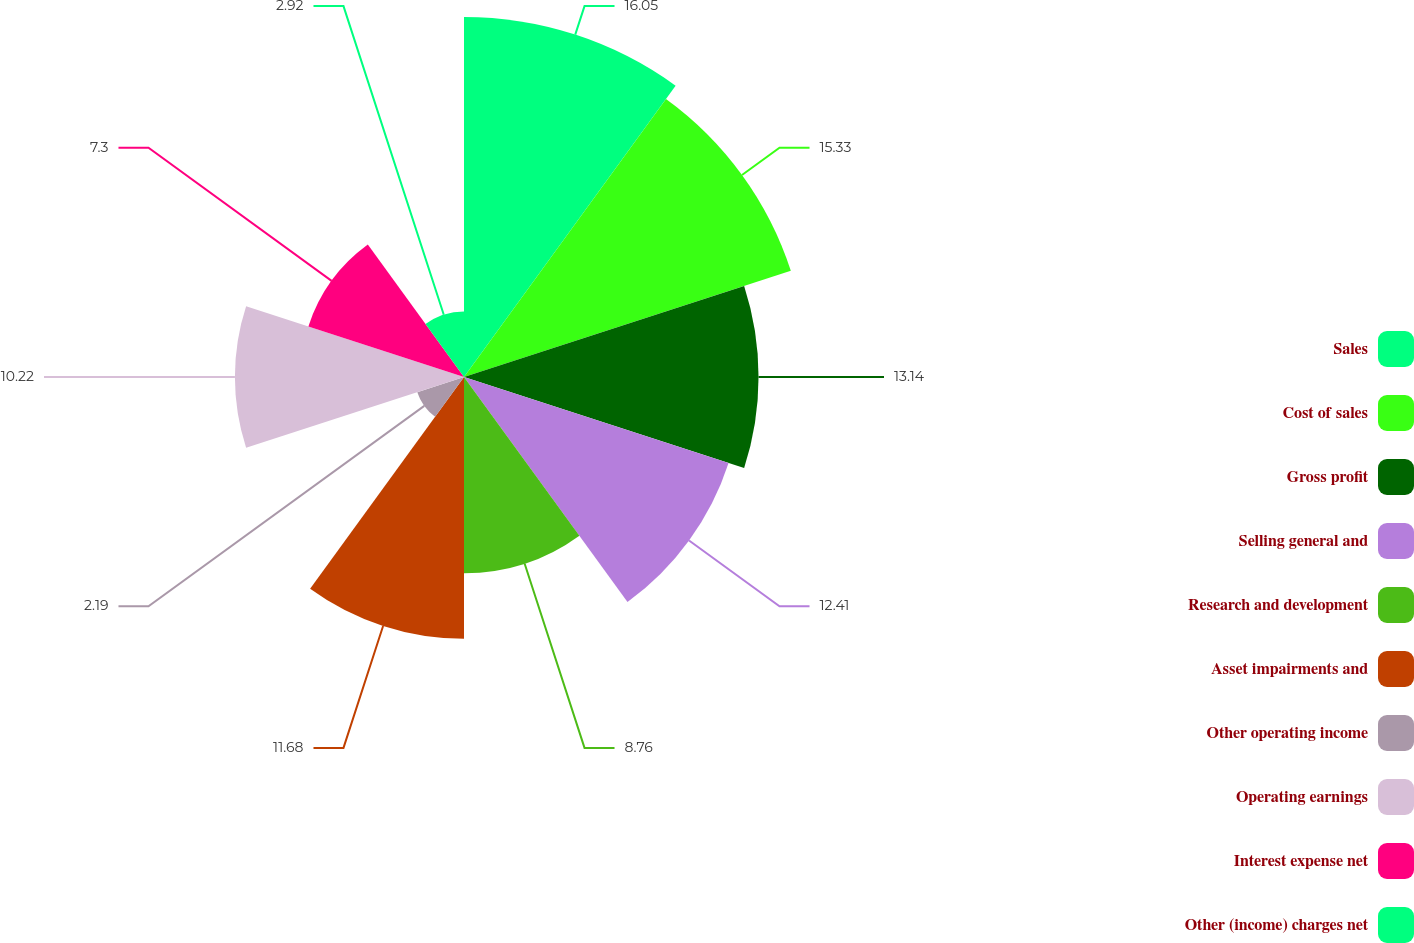<chart> <loc_0><loc_0><loc_500><loc_500><pie_chart><fcel>Sales<fcel>Cost of sales<fcel>Gross profit<fcel>Selling general and<fcel>Research and development<fcel>Asset impairments and<fcel>Other operating income<fcel>Operating earnings<fcel>Interest expense net<fcel>Other (income) charges net<nl><fcel>16.06%<fcel>15.33%<fcel>13.14%<fcel>12.41%<fcel>8.76%<fcel>11.68%<fcel>2.19%<fcel>10.22%<fcel>7.3%<fcel>2.92%<nl></chart> 